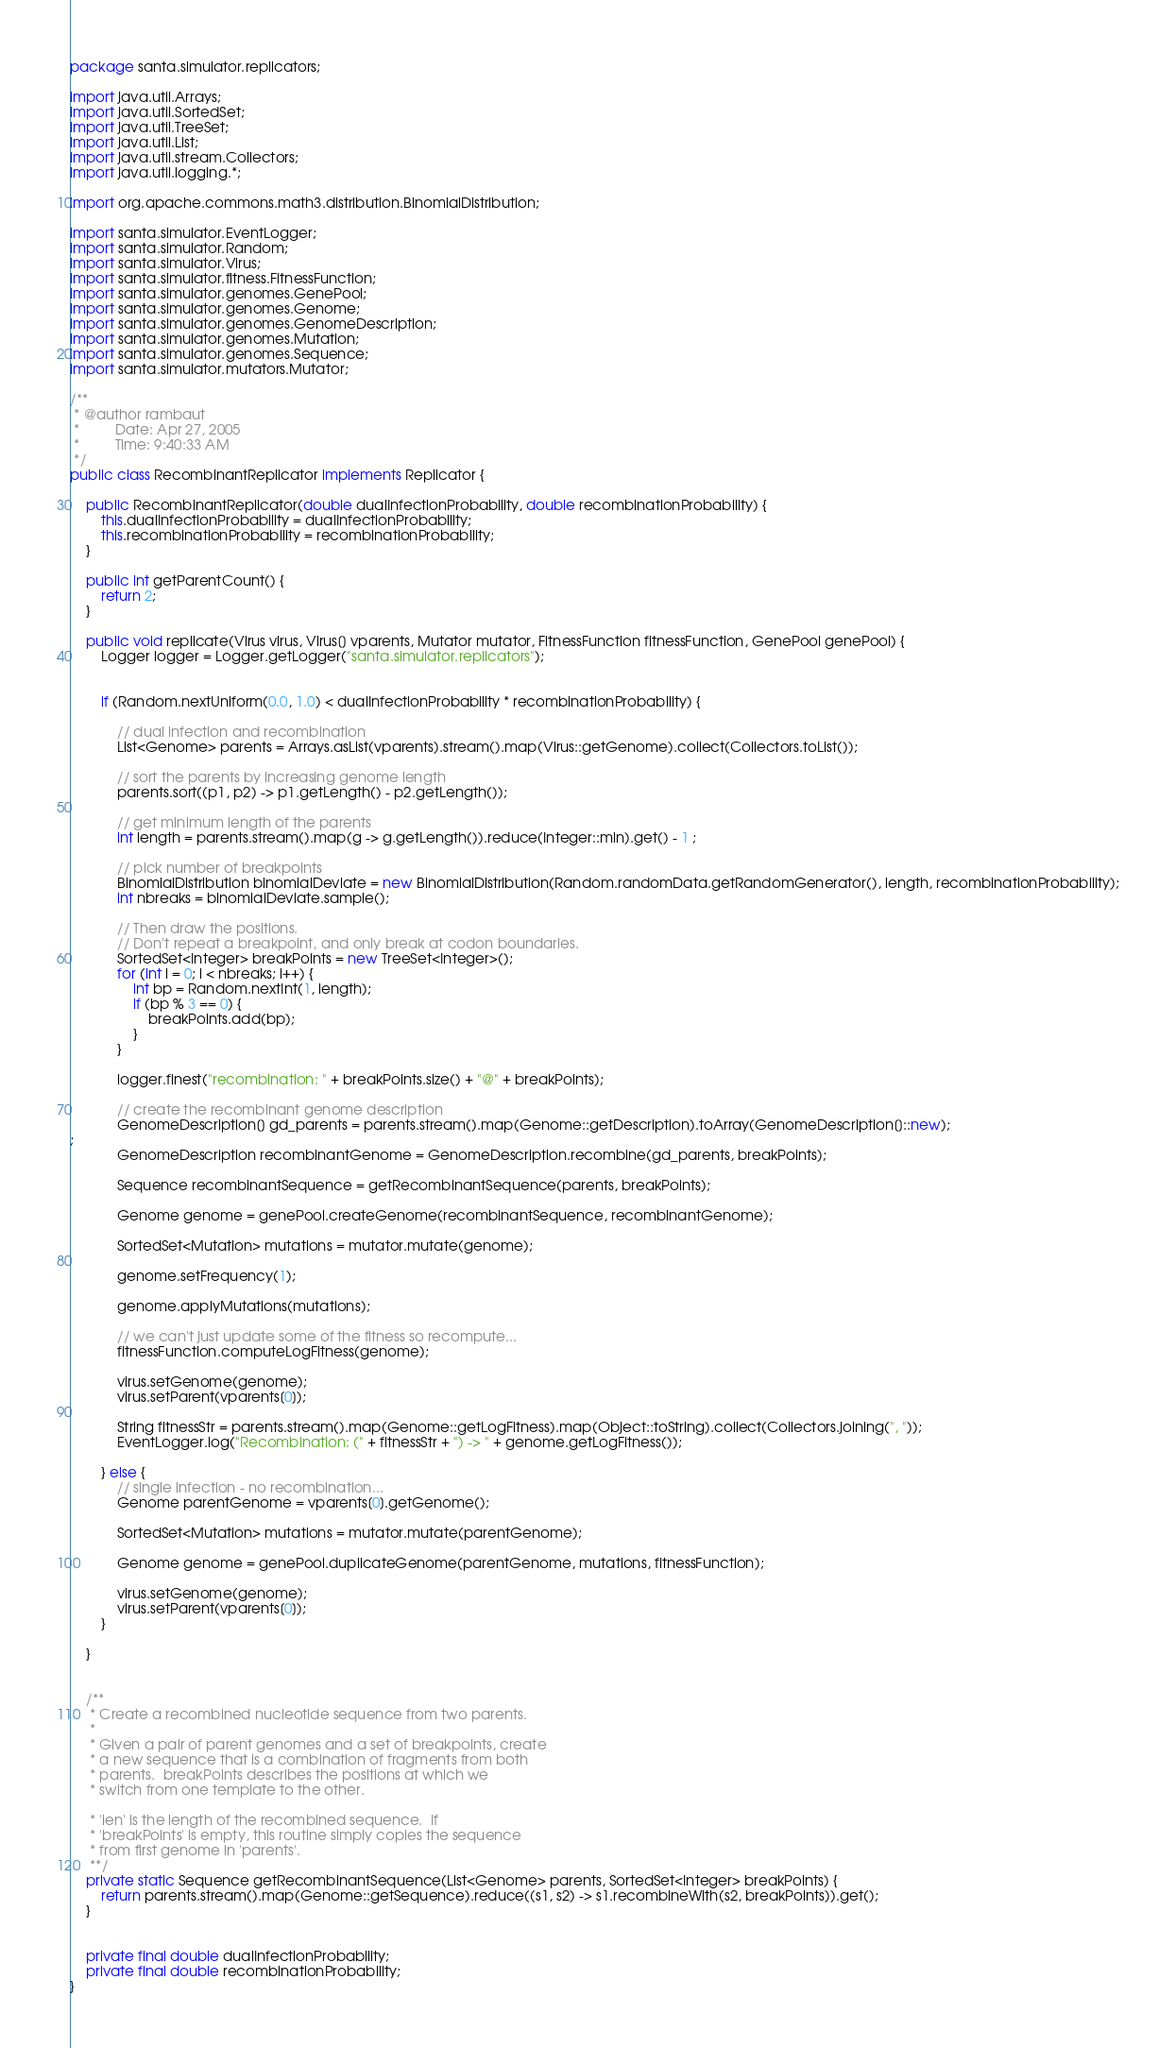<code> <loc_0><loc_0><loc_500><loc_500><_Java_>package santa.simulator.replicators;

import java.util.Arrays;
import java.util.SortedSet;
import java.util.TreeSet;
import java.util.List;
import java.util.stream.Collectors;
import java.util.logging.*;

import org.apache.commons.math3.distribution.BinomialDistribution;

import santa.simulator.EventLogger;
import santa.simulator.Random;
import santa.simulator.Virus;
import santa.simulator.fitness.FitnessFunction;
import santa.simulator.genomes.GenePool;
import santa.simulator.genomes.Genome;
import santa.simulator.genomes.GenomeDescription;
import santa.simulator.genomes.Mutation;
import santa.simulator.genomes.Sequence;
import santa.simulator.mutators.Mutator;

/**
 * @author rambaut
 *         Date: Apr 27, 2005
 *         Time: 9:40:33 AM
 */
public class RecombinantReplicator implements Replicator {

    public RecombinantReplicator(double dualInfectionProbability, double recombinationProbability) {
        this.dualInfectionProbability = dualInfectionProbability;
        this.recombinationProbability = recombinationProbability;
    }

	public int getParentCount() {
		return 2;
	}

    public void replicate(Virus virus, Virus[] vparents, Mutator mutator, FitnessFunction fitnessFunction, GenePool genePool) {
		Logger logger = Logger.getLogger("santa.simulator.replicators");


        if (Random.nextUniform(0.0, 1.0) < dualInfectionProbability * recombinationProbability) {

            // dual infection and recombination
			List<Genome> parents = Arrays.asList(vparents).stream().map(Virus::getGenome).collect(Collectors.toList());

			// sort the parents by increasing genome length
			parents.sort((p1, p2) -> p1.getLength() - p2.getLength());

			// get minimum length of the parents
			int length = parents.stream().map(g -> g.getLength()).reduce(Integer::min).get() - 1 ;

			// pick number of breakpoints
			BinomialDistribution binomialDeviate = new BinomialDistribution(Random.randomData.getRandomGenerator(), length, recombinationProbability);
			int nbreaks = binomialDeviate.sample();
			
			// Then draw the positions.
			// Don't repeat a breakpoint, and only break at codon boundaries.
			SortedSet<Integer> breakPoints = new TreeSet<Integer>();
			for (int i = 0; i < nbreaks; i++) {
				int bp = Random.nextInt(1, length);
				if (bp % 3 == 0) {
					breakPoints.add(bp);
				}
			}

			logger.finest("recombination: " + breakPoints.size() + "@" + breakPoints);

			// create the recombinant genome description
			GenomeDescription[] gd_parents = parents.stream().map(Genome::getDescription).toArray(GenomeDescription[]::new);
;
			GenomeDescription recombinantGenome = GenomeDescription.recombine(gd_parents, breakPoints);
			
			Sequence recombinantSequence = getRecombinantSequence(parents, breakPoints);

			Genome genome = genePool.createGenome(recombinantSequence, recombinantGenome);
			
	        SortedSet<Mutation> mutations = mutator.mutate(genome);

	        genome.setFrequency(1);

	        genome.applyMutations(mutations);

	        // we can't just update some of the fitness so recompute...
	        fitnessFunction.computeLogFitness(genome);

            virus.setGenome(genome);
            virus.setParent(vparents[0]);
			
            String fitnessStr = parents.stream().map(Genome::getLogFitness).map(Object::toString).collect(Collectors.joining(", "));
            EventLogger.log("Recombination: (" + fitnessStr + ") -> " + genome.getLogFitness());

        } else {
            // single infection - no recombination...
            Genome parentGenome = vparents[0].getGenome();

            SortedSet<Mutation> mutations = mutator.mutate(parentGenome);

            Genome genome = genePool.duplicateGenome(parentGenome, mutations, fitnessFunction);

            virus.setGenome(genome);
            virus.setParent(vparents[0]);
        }

    }


	/**
	 * Create a recombined nucleotide sequence from two parents.
	 *
	 * Given a pair of parent genomes and a set of breakpoints, create
	 * a new sequence that is a combination of fragments from both
	 * parents.  breakPoints describes the positions at which we
	 * switch from one template to the other.  

	 * 'len' is the length of the recombined sequence.  If
	 * 'breakPoints' is empty, this routine simply copies the sequence
	 * from first genome in 'parents'.
	 **/
    private static Sequence getRecombinantSequence(List<Genome> parents, SortedSet<Integer> breakPoints) {
		return parents.stream().map(Genome::getSequence).reduce((s1, s2) -> s1.recombineWith(s2, breakPoints)).get();
	}


    private final double dualInfectionProbability;
    private final double recombinationProbability;
}
</code> 